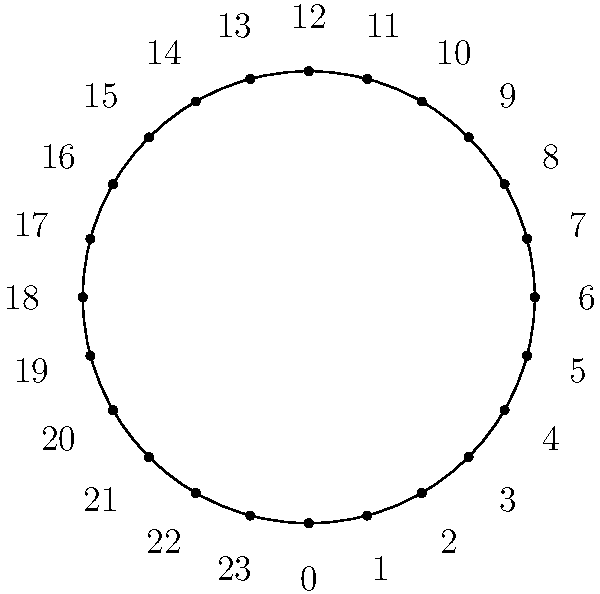As a singer-songwriter using a streaming service, you've noticed patterns in your listeners' behavior. The 24-hour clock diagram shows streaming activity levels throughout the day. Red indicates peak hours, green represents medium activity, and blue shows low activity periods. What is the total duration of peak streaming hours? To determine the total duration of peak streaming hours, we need to follow these steps:

1. Identify the peak hours on the diagram:
   The red arc represents peak streaming hours.

2. Determine the start and end times of the peak period:
   The red arc starts at 10:00 and ends at 14:00.

3. Calculate the duration:
   14:00 - 10:00 = 4 hours

Therefore, the total duration of peak streaming hours is 4 hours.

This information is crucial for a singer-songwriter to optimize their release schedule and promotional activities to maximize audience engagement and potential earnings from the streaming platform.
Answer: 4 hours 